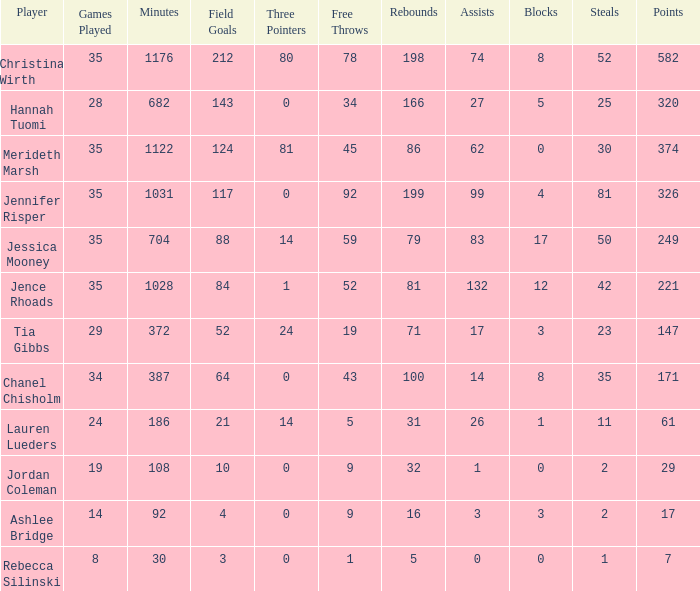How many blockings occured in the game with 198 rebounds? 8.0. Give me the full table as a dictionary. {'header': ['Player', 'Games Played', 'Minutes', 'Field Goals', 'Three Pointers', 'Free Throws', 'Rebounds', 'Assists', 'Blocks', 'Steals', 'Points'], 'rows': [['Christina Wirth', '35', '1176', '212', '80', '78', '198', '74', '8', '52', '582'], ['Hannah Tuomi', '28', '682', '143', '0', '34', '166', '27', '5', '25', '320'], ['Merideth Marsh', '35', '1122', '124', '81', '45', '86', '62', '0', '30', '374'], ['Jennifer Risper', '35', '1031', '117', '0', '92', '199', '99', '4', '81', '326'], ['Jessica Mooney', '35', '704', '88', '14', '59', '79', '83', '17', '50', '249'], ['Jence Rhoads', '35', '1028', '84', '1', '52', '81', '132', '12', '42', '221'], ['Tia Gibbs', '29', '372', '52', '24', '19', '71', '17', '3', '23', '147'], ['Chanel Chisholm', '34', '387', '64', '0', '43', '100', '14', '8', '35', '171'], ['Lauren Lueders', '24', '186', '21', '14', '5', '31', '26', '1', '11', '61'], ['Jordan Coleman', '19', '108', '10', '0', '9', '32', '1', '0', '2', '29'], ['Ashlee Bridge', '14', '92', '4', '0', '9', '16', '3', '3', '2', '17'], ['Rebecca Silinski', '8', '30', '3', '0', '1', '5', '0', '0', '1', '7']]} 